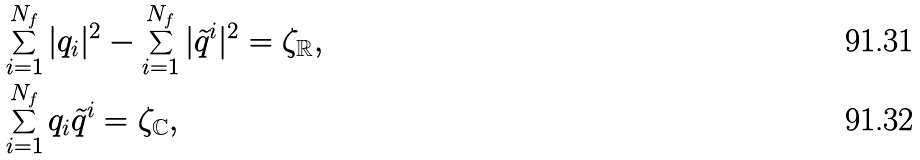Convert formula to latex. <formula><loc_0><loc_0><loc_500><loc_500>& \sum _ { i = 1 } ^ { N _ { f } } | q _ { i } | ^ { 2 } - \sum _ { i = 1 } ^ { N _ { f } } | \tilde { q } ^ { i } | ^ { 2 } = \zeta _ { \mathbb { R } } , \\ & \sum _ { i = 1 } ^ { N _ { f } } q _ { i } \tilde { q } ^ { i } = \zeta _ { \mathbb { C } } ,</formula> 